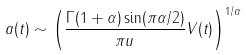Convert formula to latex. <formula><loc_0><loc_0><loc_500><loc_500>a ( t ) \sim \left ( \frac { \Gamma ( 1 + \alpha ) \sin ( \pi \alpha / 2 ) } { \pi u } V ( t ) \right ) ^ { 1 / \alpha }</formula> 